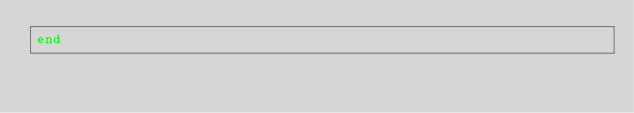<code> <loc_0><loc_0><loc_500><loc_500><_Ruby_>end</code> 